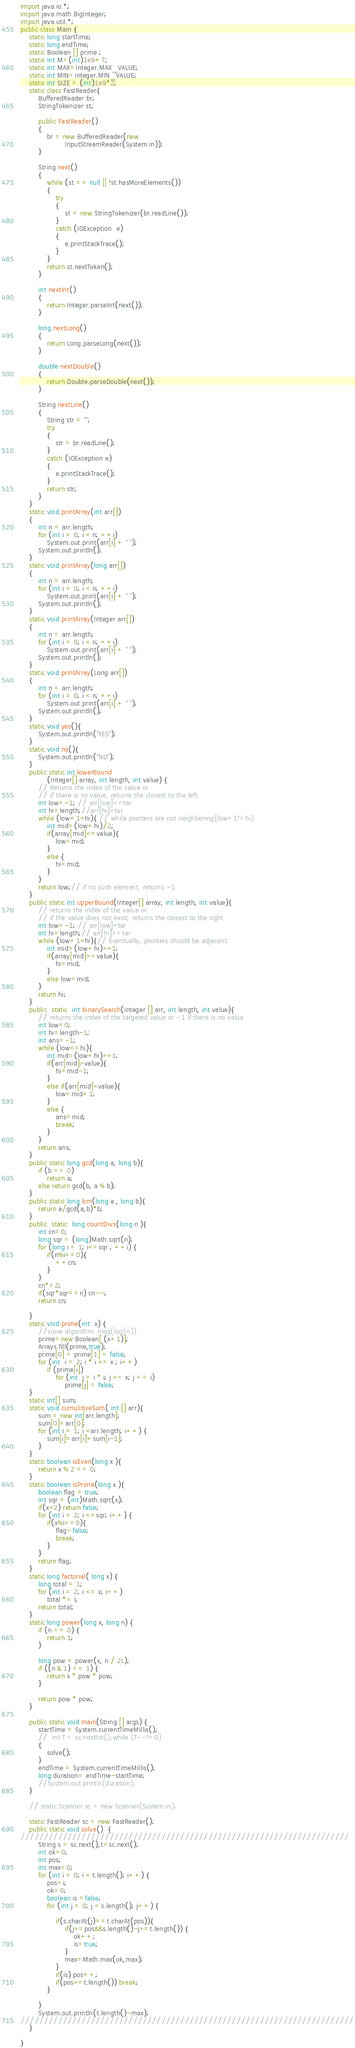Convert code to text. <code><loc_0><loc_0><loc_500><loc_500><_Java_>
import java.io.*;
import java.math.BigInteger;
import java.util.*;
public class Main {
    static long startTime;
    static long endTime;
    static Boolean [] prime ;
    static int M=(int)1e9+7;
    static int MAX=Integer.MAX_VALUE;
    static int MIN=Integer.MIN_VALUE;
    static int SIZE = (int)1e9*2;
    static class FastReader{
        BufferedReader br;
        StringTokenizer st;

        public FastReader()
        {
            br = new BufferedReader(new
                    InputStreamReader(System.in));
        }

        String next()
        {
            while (st == null || !st.hasMoreElements())
            {
                try
                {
                    st = new StringTokenizer(br.readLine());
                }
                catch (IOException  e)
                {
                    e.printStackTrace();
                }
            }
            return st.nextToken();
        }

        int nextInt()
        {
            return Integer.parseInt(next());
        }

        long nextLong()
        {
            return Long.parseLong(next());
        }

        double nextDouble()
        {
            return Double.parseDouble(next());
        }

        String nextLine()
        {
            String str = "";
            try
            {
                str = br.readLine();
            }
            catch (IOException e)
            {
                e.printStackTrace();
            }
            return str;
        }
    }
    static void printArray(int arr[])
    {
        int n = arr.length;
        for (int i = 0; i < n; ++i)
            System.out.print(arr[i] + " ");
        System.out.println();
    }
    static void printArray(long arr[])
    {
        int n = arr.length;
        for (int i = 0; i < n; ++i)
            System.out.print(arr[i] + " ");
        System.out.println();
    }
    static void printArray(Integer arr[])
    {
        int n = arr.length;
        for (int i = 0; i < n; ++i)
            System.out.print(arr[i] + " ");
        System.out.println();
    }
    static void printArray(Long arr[])
    {
        int n = arr.length;
        for (int i = 0; i < n; ++i)
            System.out.print(arr[i] + " ");
        System.out.println();
    }
    static void yes(){
        System.out.println("YES");
    }
    static void no(){
        System.out.println("NO");
    }
    public static int lowerBound
            (Integer[] array, int length, int value) {
        // Returns the index of the value or
        // if there is no value, returns the closest to the left.
        int low=-1; // arr[low]<=tar
        int hi=length;//arr[hi]>tar
        while (low+1<hi){ // while pointers are not neighboring(low+1!=hi)
            int mid=(low+hi)/2;
            if(array[mid]<=value){
                low=mid;
            }
            else {
                hi=mid;
            }
        }
        return low;// if no such element, returns -1.
    }
    public static int upperBound(Integer[] array, int length, int value){
        // returns the index of the value or
        // if the value does not exist, returns the closest to the right
        int low=-1; // arr[low]<tar
        int hi=length;// arr[hi]>=tar
        while (low+1<hi){// Eventually, pointers should be adjacent.
            int mid=(low+hi)>>1;
            if(array[mid]>=value){
                hi=mid;
            }
            else low=mid;
        }
        return hi;
    }
    public  static  int binarySearch(Integer [] arr, int length, int value){
        // returns the index of the targeted value or -1 if there is no value.
        int low=0;
        int hi=length-1;
        int ans=-1;
        while (low<=hi){
            int mid=(low+hi)>>1;
            if(arr[mid]>value){
                hi=mid-1;
            }
            else if(arr[mid]<value){
                low=mid+1;
            }
            else {
                ans=mid;
                break;
            }
        }
        return ans;
    }
    public static long gcd(long a, long b){
        if (b == 0)
            return a;
        else return gcd(b, a % b);
    }
    public static long lcm(long a , long b){
        return a/gcd(a,b)*b;
    }
    public  static  long countDivs(long n ){
        int cn=0;
        long sqr = (long)Math.sqrt(n);
        for (long i = 1; i<=sqr ; ++i) {
            if(n%i==0){
                ++cn;
            }
        }
        cn*=2;
        if(sqr*sqr==n) cn--;
        return cn;

    }
    static void prime(int  x) {
        //sieve algorithm. nlog(log(n)).
        prime=new Boolean[ (x+1)];
        Arrays.fill(prime,true);
        prime[0] = prime[1] = false;
        for (int  i = 2; i * i <= x ; i++)
            if (prime[i])
                for (int  j = i * i; j <= x; j += i)
                    prime[j] = false;
    }
    static int[] sum;
    static void cumulitiveSum( int [] arr){
        sum = new int[arr.length];
        sum[0]=arr[0];
        for (int i = 1; i <arr.length; i++) {
            sum[i]=arr[i]+sum[i-1];
        }
    }
    static boolean isEven(long x ){
        return x % 2 == 0;
    }
    static boolean isPrime(long x ){
        boolean flag = true;
        int sqr = (int)Math.sqrt(x);
        if(x<2) return false;
        for (int i = 2; i <=sqr; i++) {
            if(x%i==0){
                flag=false;
                break;
            }
        }
        return flag;
    }
    static long factorial( long x) {
        long total = 1;
        for (int i = 2; i <= x; i++)
            total *= i;
        return total;
    }
    static long power(long x, long n) {
        if (n == 0) {
            return 1;
        }

        long pow = power(x, n / 2L);
        if ((n & 1) == 1) {
            return x * pow * pow;
        }

        return pow * pow;
    }

    public static void main(String [] args) {
        startTime = System.currentTimeMillis();
        //  int T = sc.nextInt();while (T--!=0)
        {
            solve();
        }
        endTime = System.currentTimeMillis();
        long duration= endTime-startTime;
        //System.out.println(duration);
    }

    // static Scanner sc = new Scanner(System.in);

    static FastReader sc = new FastReader();
    public static void solve()  {
//////////////////////////////////////////////////////////////////////
        String s = sc.next(),t=sc.next();
        int ok=0;
        int pos;
        int max=0;
        for (int i = 0; i < t.length(); i++) {
            pos=i;
            ok=0;
            boolean is =false;
            for (int j = 0; j < s.length(); j++) {
                
                if(s.charAt(j)==t.charAt(pos)){
                    if(j>=pos&&s.length()-j>=t.length()) {
                        ok++;
                        is=true;
                    }
                    max=Math.max(ok,max);
                }
                if(is) pos++;
                if(pos>=t.length()) break;
            }

        }
        System.out.println(t.length()-max);
///////////////////////////////////////////////////////////////////////
    }

}
</code> 